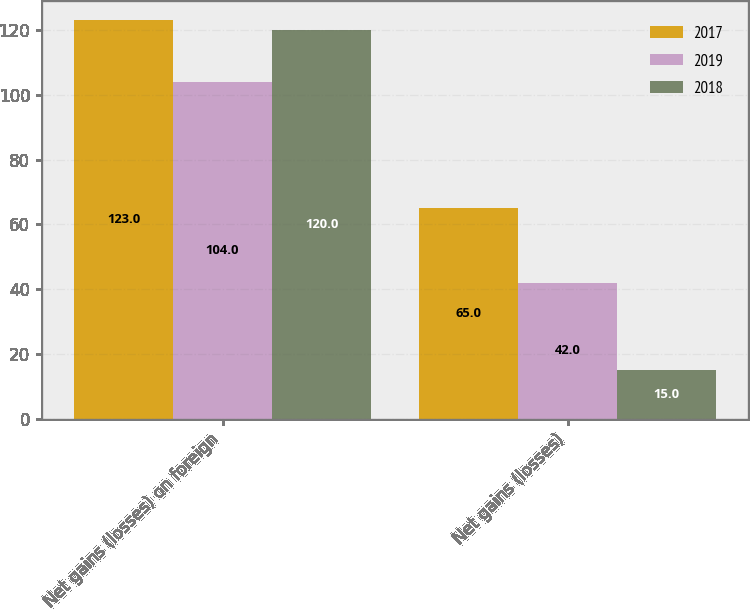<chart> <loc_0><loc_0><loc_500><loc_500><stacked_bar_chart><ecel><fcel>Net gains (losses) on foreign<fcel>Net gains (losses)<nl><fcel>2017<fcel>123<fcel>65<nl><fcel>2019<fcel>104<fcel>42<nl><fcel>2018<fcel>120<fcel>15<nl></chart> 